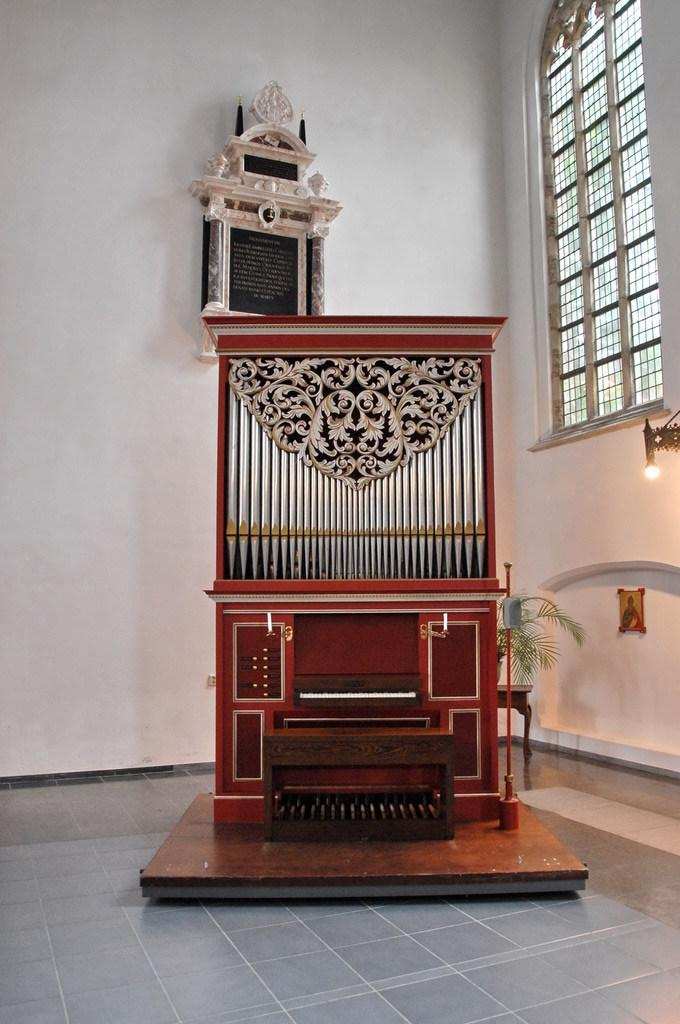What type of object is on the floor in the image? There is a wooden object on the floor. Can you describe any living organisms in the image? Yes, there is a plant in the image. What is located on the right side of the image? There is a bulb on the right side of the image. What color pattern is present on the wall in the image? There is a white and black color object on the wall. What type of cheese is being used to sew a needle in the image? There is no cheese or needle present in the image. 